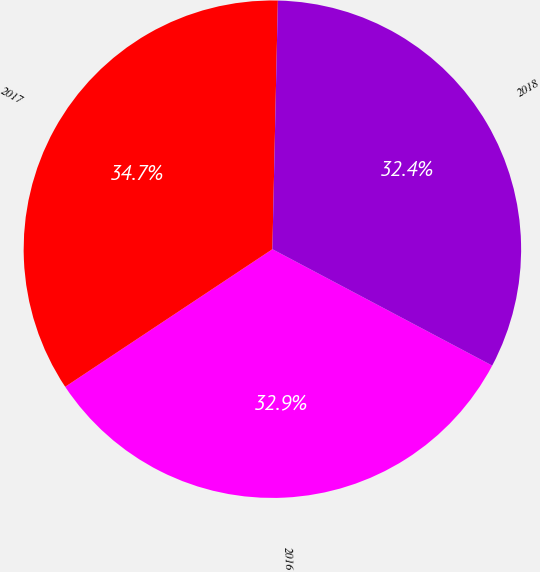<chart> <loc_0><loc_0><loc_500><loc_500><pie_chart><fcel>2016<fcel>2017<fcel>2018<nl><fcel>32.92%<fcel>34.68%<fcel>32.4%<nl></chart> 